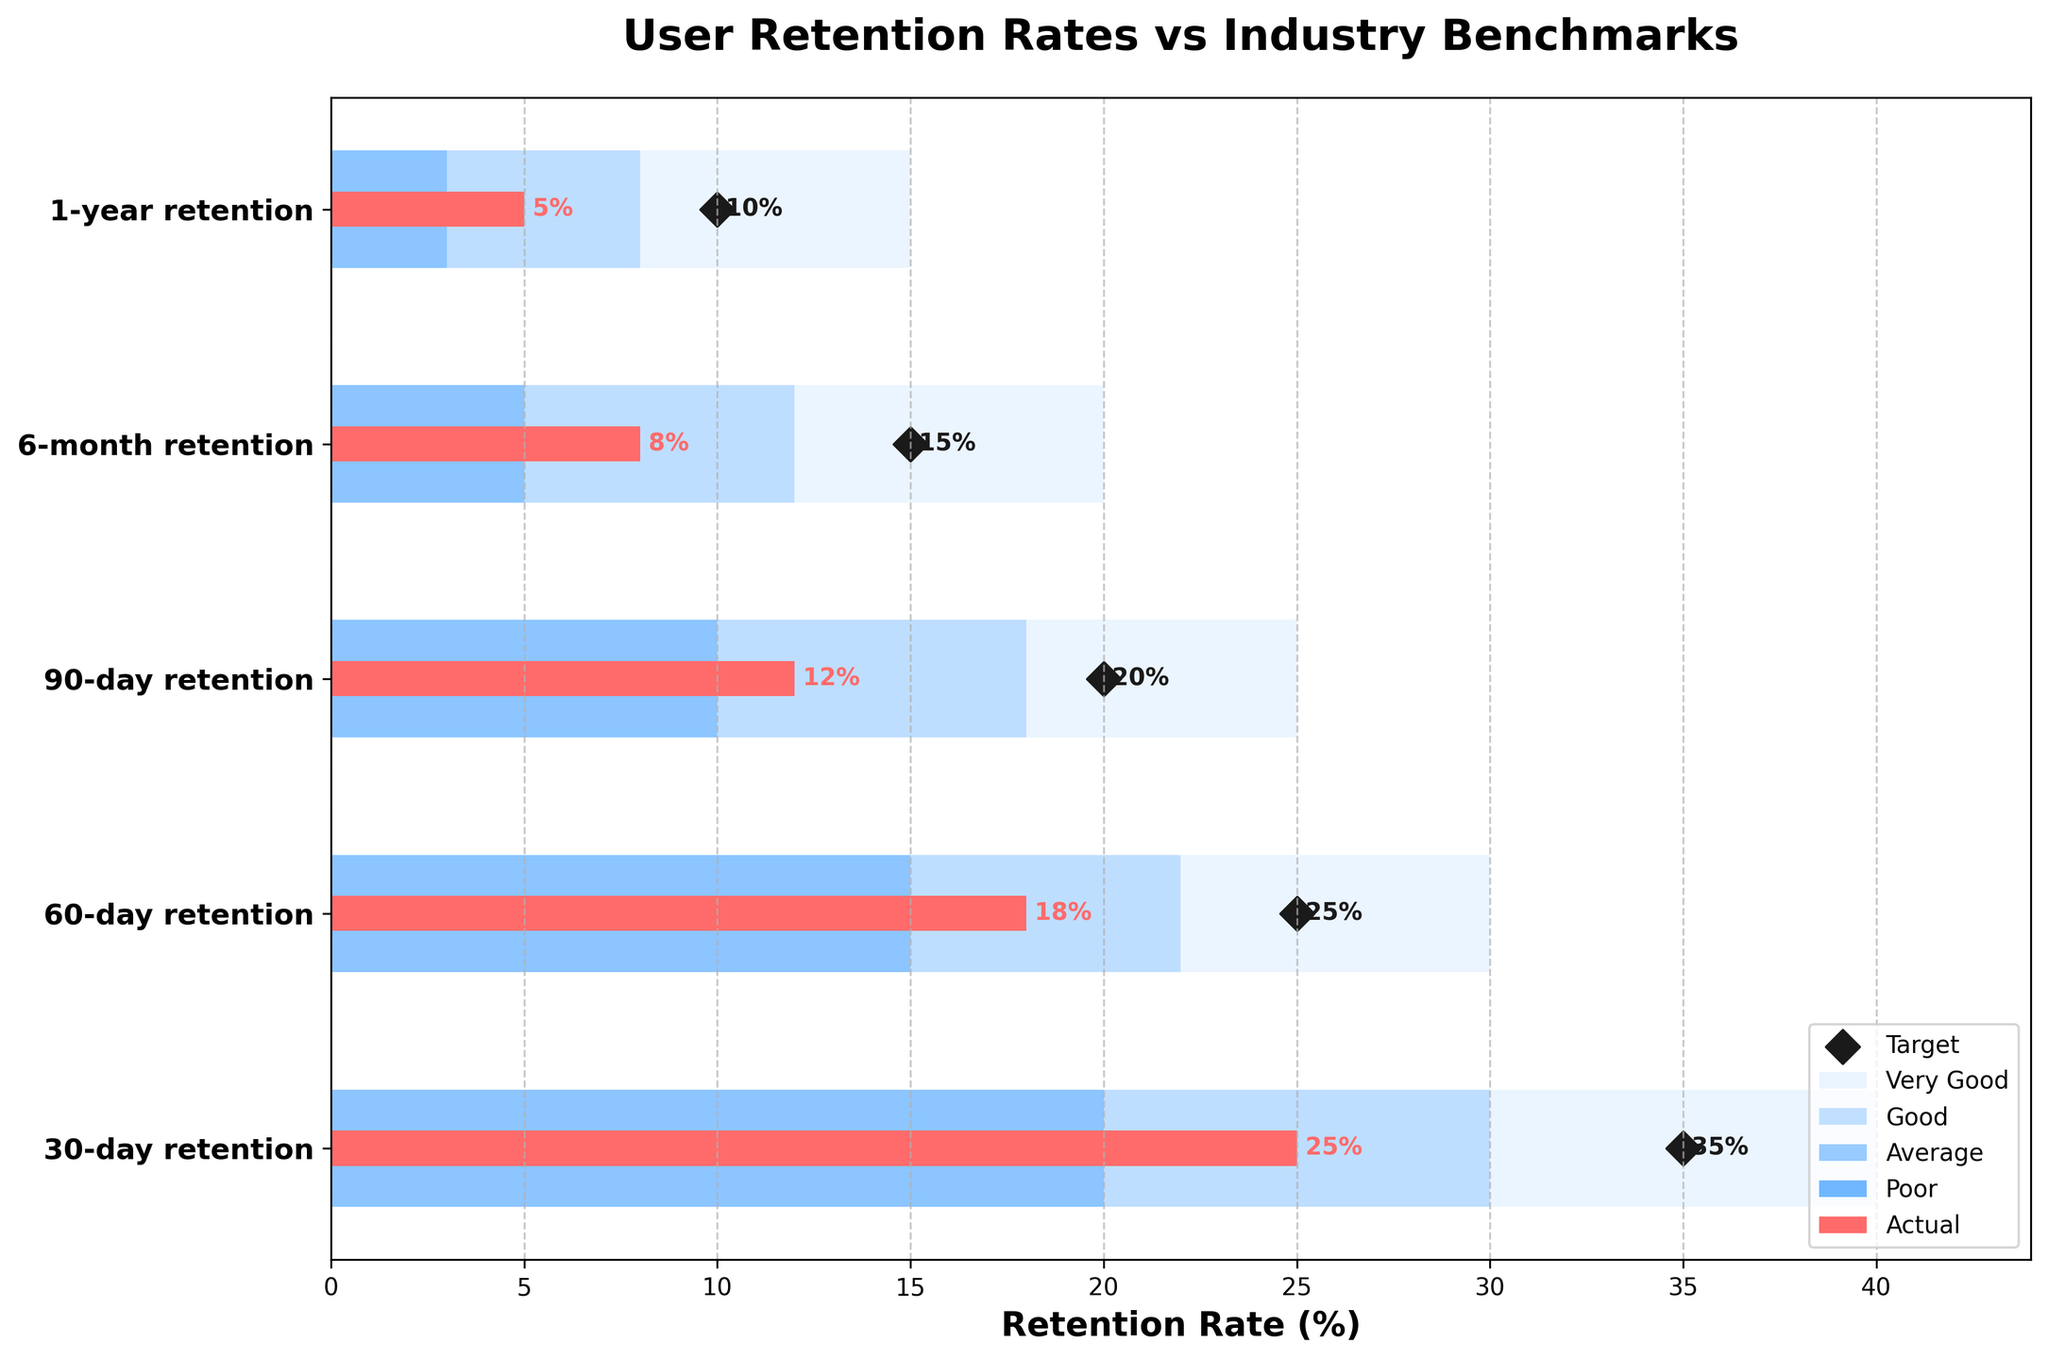what is the title of the chart? The title of the chart is usually placed at the top of the figure. In this case, it reads "User Retention Rates vs Industry Benchmarks" as it is shown at the top center of the plot.
Answer: User Retention Rates vs Industry Benchmarks How many user retention periods are illustrated in the chart? Count the number of categories listed on the y-axis. The categories are "30-day retention," "60-day retention," "90-day retention," "6-month retention," and "1-year retention," making a total of 5 periods.
Answer: 5 What is the actual 60-day retention rate? Look at the bar labeled "Actual" in the row corresponding to "60-day retention" on the chart. The value indicated on the bar is 18%.
Answer: 18% Which period shows the biggest gap between actual retention and target retention? To find the biggest gap, subtract the 'Actual' value from the 'Target' value for each period and compare them:
30-day: 35% - 25% = 10%
60-day: 25% - 18% = 7%
90-day: 20% - 12% = 8%
6-month: 15% - 8% = 7%
1-year: 10% - 5% = 5%
The biggest gap is for the 30-day retention period at 10%.
Answer: 30-day retention What is the range of the "Good" benchmark for the 1-year retention rate? The "Good" benchmark is represented as the range between the "Average" and "Very Good" bars within the 1-year row. For "1-year retention," this range starts from 8% and ends at 15%.
Answer: 8%-15% What percentage of the actual 30-day retention rate falls below the "Average" benchmark? Compare the actual 30-day retention rate (25%) with the ranges given for "Average". The "Average" range for 30-day is up to 30%. Since 25% is 5% below 30%, the percentage below the "Average" benchmark is approximately 5%.
Answer: 5% Which retention period performs above the "Poor" benchmark but below the "Average" benchmark? Check each retention period where the actual rate is above the "Poor" benchmark and below the "Average" benchmark:
30-day: 25% (Above "Average", 20% - 30%)
60-day: 18% (Above "Poor" but below "Average", 15% - 22%)
90-day: 12% (Above "Poor" but below "Average", 10% - 18%)
6-month: 8% (Above "Poor" but below "Average", 5% - 12%)
1-year: 5% (Above "Poor" but below "Average", 3% - 8%)
For "60-day", "90-day", "6-month", and "1-year" periods, the rates fit the description.
Answer: 60-day, 90-day, 6-month, and 1-year retention How does the actual 90-day retention rate compare to its "Good" benchmark? The actual 90-day retention rate is 12%. The "Good" benchmark range for 90-day retention spans from 18% to 25%. Since 12% is below this range, it does not meet the "Good" benchmark.
Answer: Below "Good" In which retention period is the actual rate equal to or higher than the "Poor" benchmark? Check each retention period where the actual rate is equal to or higher than the "Poor" benchmark:
30-day: 25% (>= 0)
60-day: 18% (>= 0)
90-day: 12% (>= 0)
6-month: 8% (>= 0)
1-year: 5% (>= 0)
In all periods (30-day, 60-day, 90-day, 6-month, 1-year), the actual rates meet or exceed the "Poor" benchmark.
Answer: All periods 